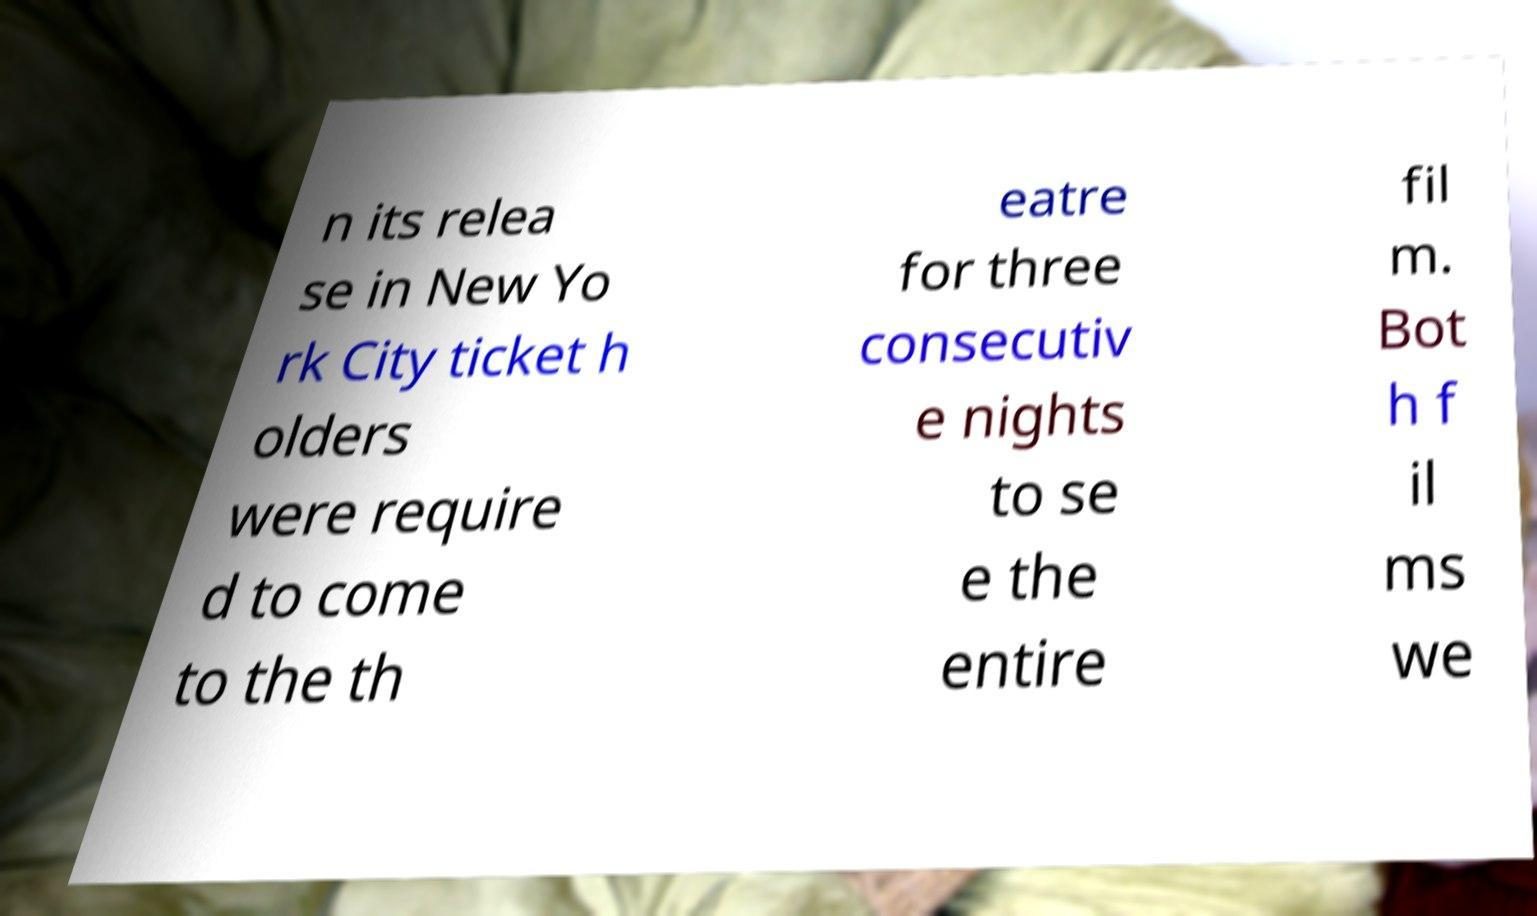There's text embedded in this image that I need extracted. Can you transcribe it verbatim? n its relea se in New Yo rk City ticket h olders were require d to come to the th eatre for three consecutiv e nights to se e the entire fil m. Bot h f il ms we 